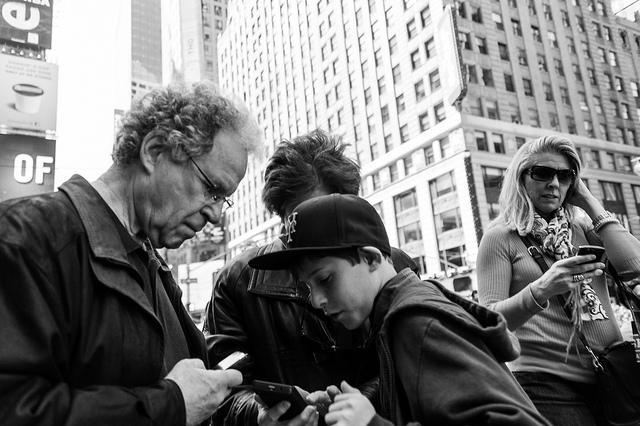What does the boy have on his head?

Choices:
A) baseball cap
B) cat
C) balloon
D) fedora baseball cap 